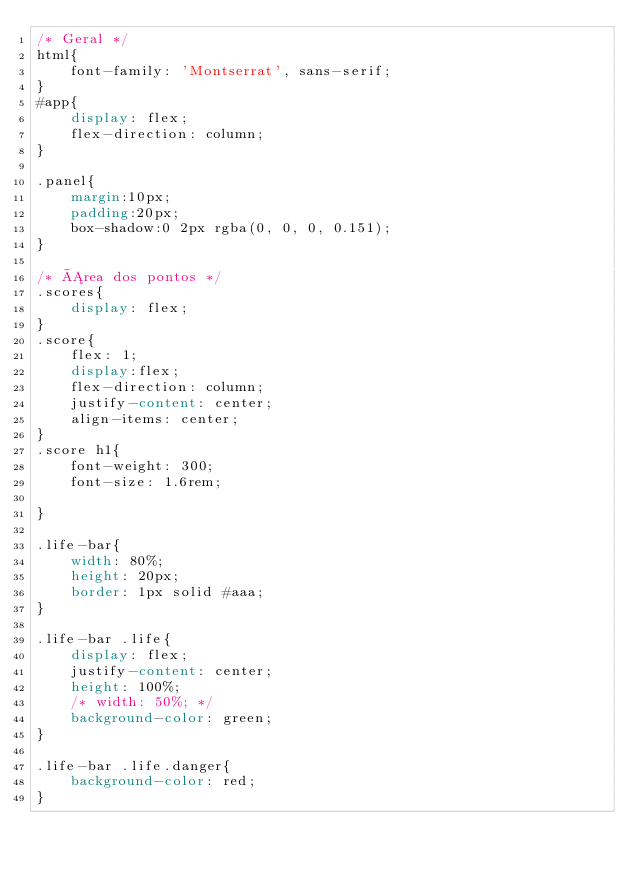<code> <loc_0><loc_0><loc_500><loc_500><_CSS_>/* Geral */
html{
    font-family: 'Montserrat', sans-serif;
}
#app{
    display: flex;
    flex-direction: column;
}

.panel{
    margin:10px;
    padding:20px;
    box-shadow:0 2px rgba(0, 0, 0, 0.151);
}

/* Área dos pontos */
.scores{
    display: flex;
}
.score{
    flex: 1;
    display:flex;
    flex-direction: column;
    justify-content: center;
    align-items: center;
}
.score h1{
    font-weight: 300;
    font-size: 1.6rem;

}

.life-bar{
    width: 80%;
    height: 20px;
    border: 1px solid #aaa;
}

.life-bar .life{
    display: flex;
    justify-content: center;
    height: 100%;
    /* width: 50%; */
    background-color: green;
}

.life-bar .life.danger{
    background-color: red;
}
</code> 